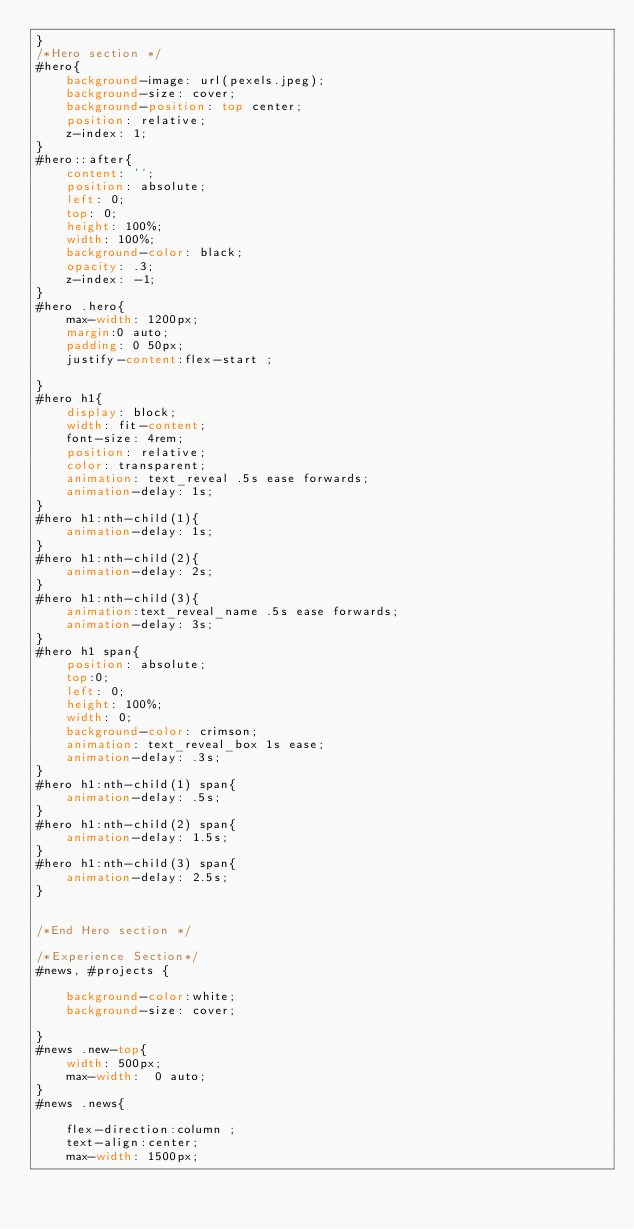Convert code to text. <code><loc_0><loc_0><loc_500><loc_500><_CSS_>}
/*Hero section */
#hero{
    background-image: url(pexels.jpeg);
    background-size: cover;
    background-position: top center;
    position: relative;
    z-index: 1;
}
#hero::after{
    content: '';
    position: absolute;
    left: 0;
    top: 0;
    height: 100%;
    width: 100%;
    background-color: black;
    opacity: .3;
    z-index: -1;
}
#hero .hero{
    max-width: 1200px;
    margin:0 auto;
    padding: 0 50px;
    justify-content:flex-start ;

}
#hero h1{
    display: block;
    width: fit-content;
    font-size: 4rem;
    position: relative;
    color: transparent;
    animation: text_reveal .5s ease forwards;
    animation-delay: 1s;
}
#hero h1:nth-child(1){
    animation-delay: 1s;
}
#hero h1:nth-child(2){
    animation-delay: 2s;
}
#hero h1:nth-child(3){
    animation:text_reveal_name .5s ease forwards;
    animation-delay: 3s;
}
#hero h1 span{
    position: absolute;
    top:0;
    left: 0;
    height: 100%;
    width: 0;
    background-color: crimson;
    animation: text_reveal_box 1s ease;
    animation-delay: .3s;
}
#hero h1:nth-child(1) span{
    animation-delay: .5s;
}
#hero h1:nth-child(2) span{
    animation-delay: 1.5s;
}
#hero h1:nth-child(3) span{
    animation-delay: 2.5s;
}


/*End Hero section */

/*Experience Section*/
#news, #projects {
    
    background-color:white;
    background-size: cover; 
        
}
#news .new-top{
    width: 500px;
    max-width:  0 auto;
}
#news .news{

    flex-direction:column ;
    text-align:center;
    max-width: 1500px;</code> 